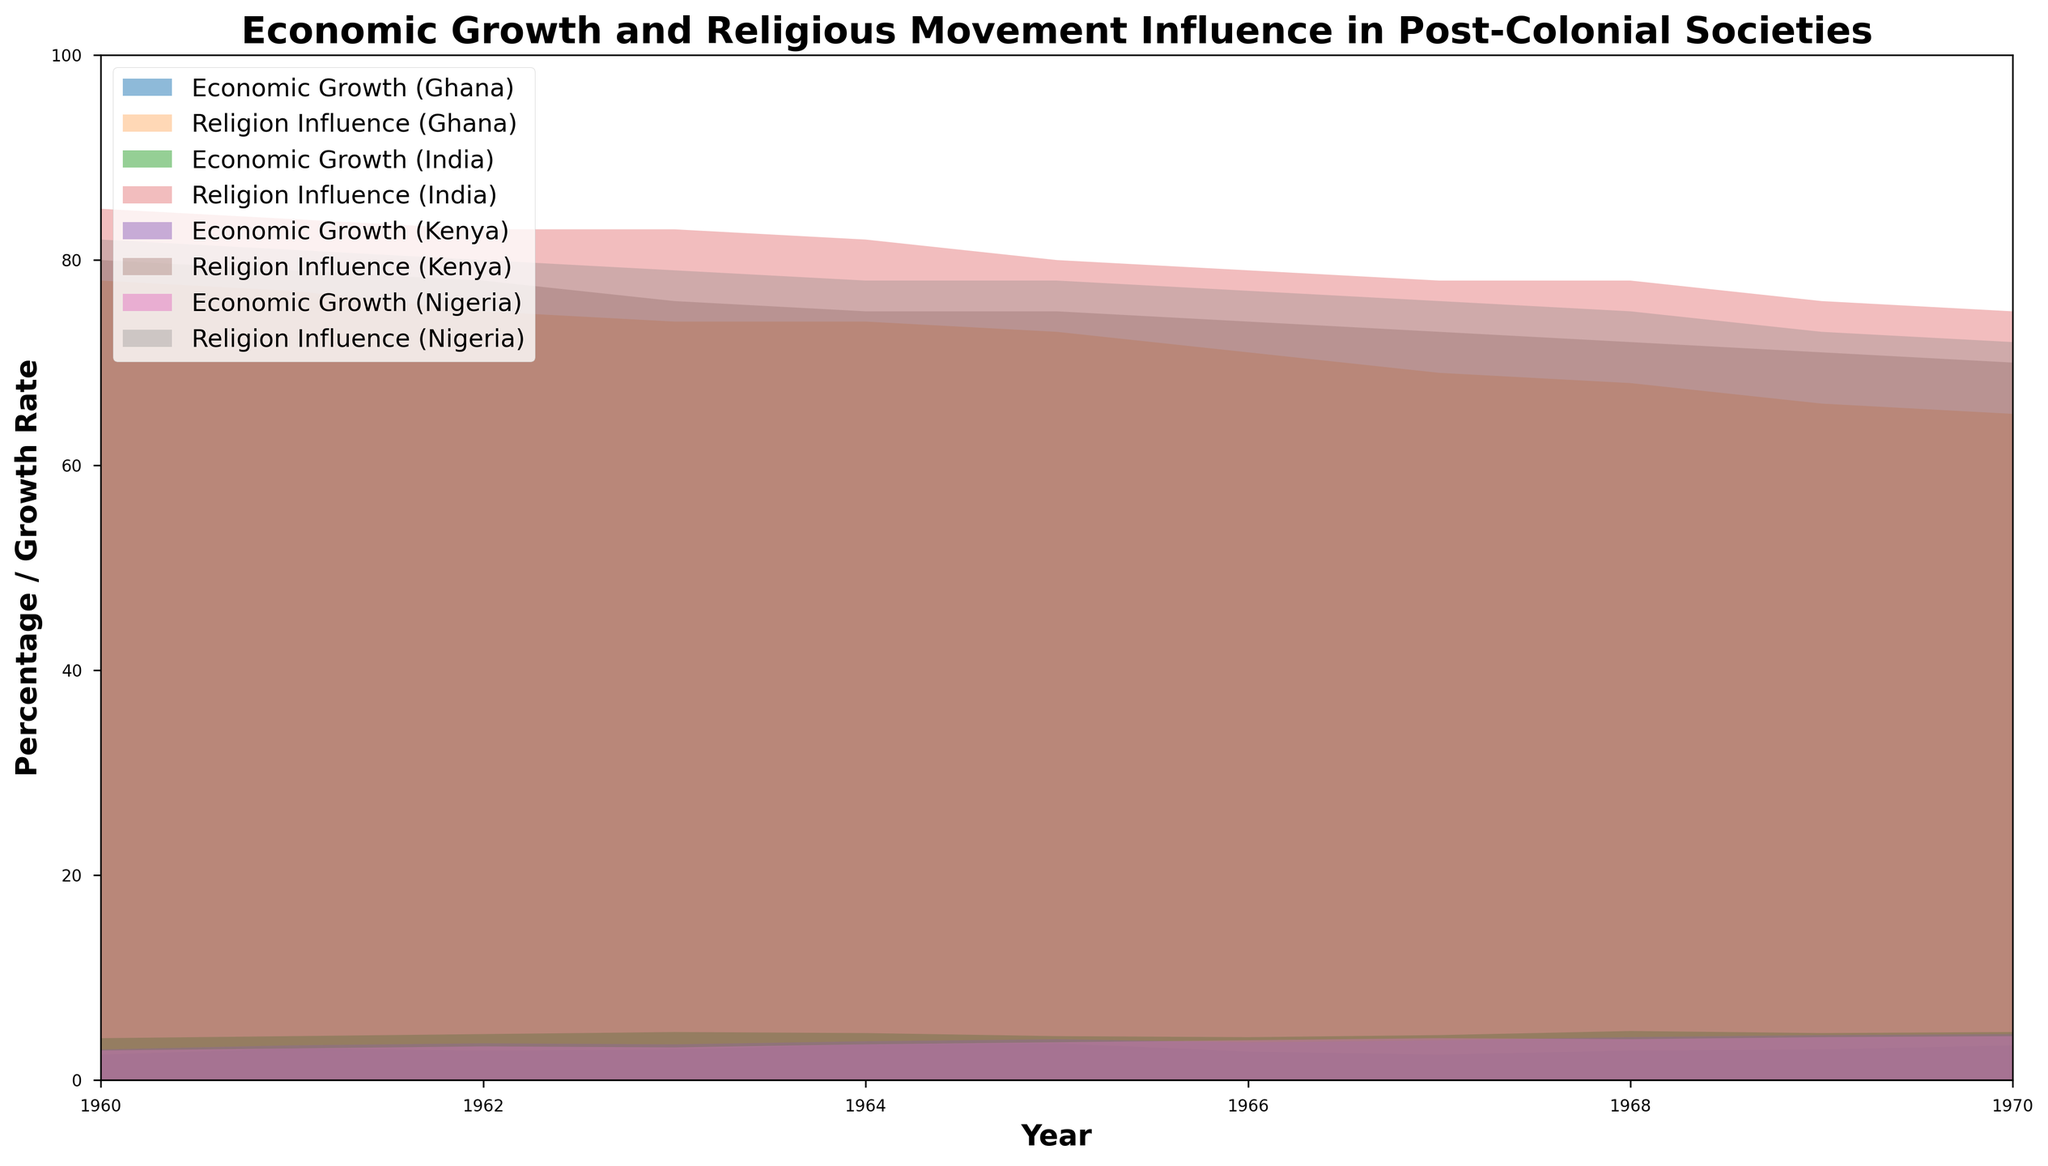How does the economic growth trend for Ghana change from 1960 to 1970? The economic growth in Ghana fluctuates slightly over the decade. It starts at 2.5% in 1960, peaks at 3.6% in 1965, then drops to 2.8% in 1966, and gradually increases again, reaching around 3.4% by 1970.
Answer: It fluctuates and slightly increases Compare the religious influence in Kenya and Nigeria in 1965. Which country had higher influence, and by how much? In 1965, the religious influence in Kenya was 75, and in Nigeria, it was 78. The difference between the two is 78 - 75 = 3, meaning Nigeria had a higher religious influence by 3 percentage points.
Answer: Nigeria by 3 percentage points Which country showed the greatest consistency in economic growth from 1960 to 1970? By observing the chart, India demonstrates the most consistent economic growth over the years compared to the other countries. Its growth rate stays relatively stable, varying only slightly between 4.1% and 4.8%.
Answer: India What is the trend of religious influence for Ghana over the decade, 1960 to 1970? The religious influence in Ghana gradually decreases over the decade. It starts at 78% in 1960 and drops to 65% by 1970.
Answer: Gradually decreases In which year does Nigeria achieve its highest economic growth rate, and what is that rate? Refer to the fill for Nigeria’s economic growth. The highest growth occurs in 1970, reaching 4.3%.
Answer: 1970, 4.3% Compare the economic growth in Kenya and Ghana in the year 1964. Which country had a higher growth rate, and by how much? In 1964, Kenya’s economic growth rate is 3.8%, while Ghana's is 3.5%. The difference between the two is 3.8% - 3.5% = 0.3%, indicating that Kenya had a higher growth rate by 0.3%.
Answer: Kenya by 0.3% What unique pattern do we see in the economic growth and religious influence in India from 1960 to 1970? In India, as the economic growth slightly increases from 4.1% to 4.7%, the religious influence gradually decreases from 85% to 75%. This indicates an inverse relationship: as the economy grows, religious influence dims.
Answer: Inverse relationship Which country had the highest decline in religious influence from 1960 to 1970, and by how much did it decline? Referring to the graph for each country's religious influence, the steepest decline is seen in Nigeria, where it dropped from 82% in 1960 to 72% in 1970, totaling a decline of 10 percentage points.
Answer: Nigeria, 10 percentage points How did the economic growth of Nigeria compare to that of Kenya in 1968? In 1968, Nigeria’s economic growth was 4.0%, and Kenya’s was 4.2%. Hence, Kenya had a 0.2% higher economic growth rate than Nigeria.
Answer: Kenya by 0.2% Analyze the relationship between economic growth and religious influence in Kenya from 1960 to 1970. Kenya shows a pattern where religious influence decreases (from 80% in 1960 to 70% in 1970) as economic growth increases (from 3.0% in 1960 to 4.5% in 1970). This implies a possible inverse correlation where economic development may relate to a decrease in religious influence.
Answer: Inverse correlation 